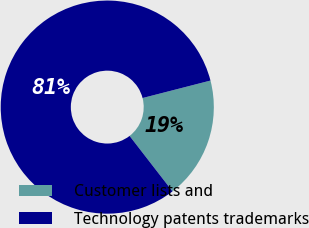Convert chart. <chart><loc_0><loc_0><loc_500><loc_500><pie_chart><fcel>Customer lists and<fcel>Technology patents trademarks<nl><fcel>18.52%<fcel>81.48%<nl></chart> 